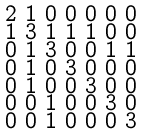Convert formula to latex. <formula><loc_0><loc_0><loc_500><loc_500>\begin{smallmatrix} 2 & 1 & 0 & 0 & 0 & 0 & 0 \\ 1 & 3 & 1 & 1 & 1 & 0 & 0 \\ 0 & 1 & 3 & 0 & 0 & 1 & 1 \\ 0 & 1 & 0 & 3 & 0 & 0 & 0 \\ 0 & 1 & 0 & 0 & 3 & 0 & 0 \\ 0 & 0 & 1 & 0 & 0 & 3 & 0 \\ 0 & 0 & 1 & 0 & 0 & 0 & 3 \end{smallmatrix}</formula> 